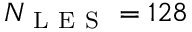<formula> <loc_0><loc_0><loc_500><loc_500>N _ { L E S } = 1 2 8</formula> 